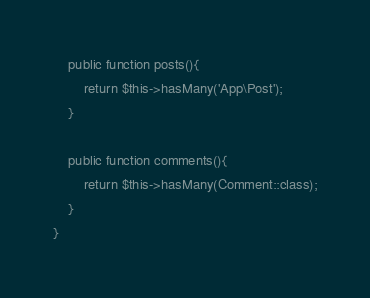<code> <loc_0><loc_0><loc_500><loc_500><_PHP_>    public function posts(){
        return $this->hasMany('App\Post');
    }

    public function comments(){
        return $this->hasMany(Comment::class);
    }
}
</code> 